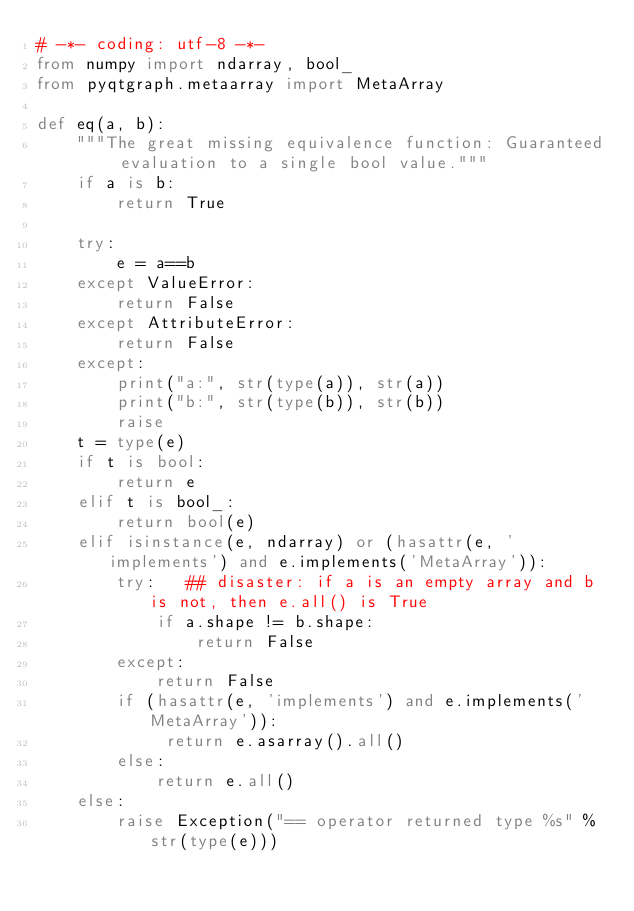Convert code to text. <code><loc_0><loc_0><loc_500><loc_500><_Python_># -*- coding: utf-8 -*-
from numpy import ndarray, bool_
from pyqtgraph.metaarray import MetaArray

def eq(a, b):
    """The great missing equivalence function: Guaranteed evaluation to a single bool value."""
    if a is b:
        return True
        
    try:
        e = a==b
    except ValueError:
        return False
    except AttributeError: 
        return False
    except:
        print("a:", str(type(a)), str(a))
        print("b:", str(type(b)), str(b))
        raise
    t = type(e)
    if t is bool:
        return e
    elif t is bool_:
        return bool(e)
    elif isinstance(e, ndarray) or (hasattr(e, 'implements') and e.implements('MetaArray')):
        try:   ## disaster: if a is an empty array and b is not, then e.all() is True
            if a.shape != b.shape:
                return False
        except:
            return False
        if (hasattr(e, 'implements') and e.implements('MetaArray')):
             return e.asarray().all()
        else:
            return e.all()
    else:
        raise Exception("== operator returned type %s" % str(type(e)))
</code> 